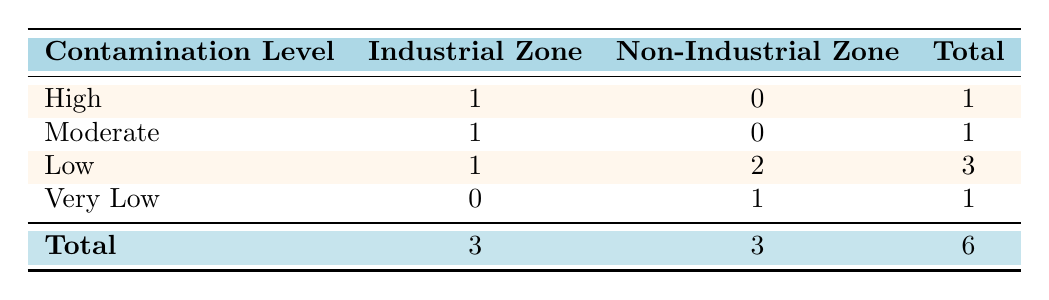What is the total number of water samples collected from industrial zones? According to the table, there are 3 samples listed under the Industrial Zone. The total can be found in the 'Total' column below the Industrial Zone row, which sums the individual contamination levels – High (1), Moderate (1), and Low (1). Adding these gives: 1 + 1 + 1 = 3.
Answer: 3 How many contamination levels categorized as 'Low' were found in non-industrial zones? The table indicates that there are 2 instances of 'Low' contamination levels under the Non-Industrial Zone: one from Riverbend Village and the other is Clearwater National Park. The count of these instances in the table is indicated in the 'Low' row for the Non-Industrial Zone, which states there are 2.
Answer: 2 Is there any contamination level in the non-industrial zone that is categorized as 'High'? The table shows that there are '0' instances of the contamination level categorized as 'High' in the Non-Industrial Zone. Therefore, the answer is based on checking the specific row for 'High' contamination level in Non-Industrial Zone, which confirms it is indeed zero.
Answer: No Which zone has the highest level of contamination based on the provided data? Looking at the 'High' contamination level row, we see that it is only present in the Industrial Zone with 1 instance. The Non-Industrial Zone shows no instances of 'High' contamination, so it can be concluded that the Industrial Zone is where the highest contamination level is found.
Answer: Industrial Zone What is the ratio of 'Moderate' contamination levels in industrial zones to those in non-industrial zones? There is 1 instance of 'Moderate' contamination in the Industrial Zone and 0 in the Non-Industrial Zone. The ratio can be calculated as 1 (Moderate in Industrial) to 0 (Moderate in Non-Industrial), but since you cannot divide by zero, it indicates that there are no corresponding instances in the Non-Industrial Zone. Therefore, it implies no comparison can be made.
Answer: Undefined How many total water samples were collected from both industrial and non-industrial zones combined? To find the total samples from both zones, we need to refer to the 'Total' row, which sums up both Industrial and Non-Industrial Zones. The total from Industrial Zone is 3 and from Non-Industrial Zone is also 3. Thus, the total is 3 + 3 = 6.
Answer: 6 What is the percentage of ‘Very Low’ contamination levels in non-industrial zones compared to the total samples? There is 1 instance of 'Very Low' in the Non-Industrial Zone. To get the percentage, we take the count of 'Very Low' in the Non-Industrial Zone (1) and divide it by the total samples (6), and then multiply by 100. The calculation is (1/6) * 100 = 16.67%.
Answer: 16.67% 